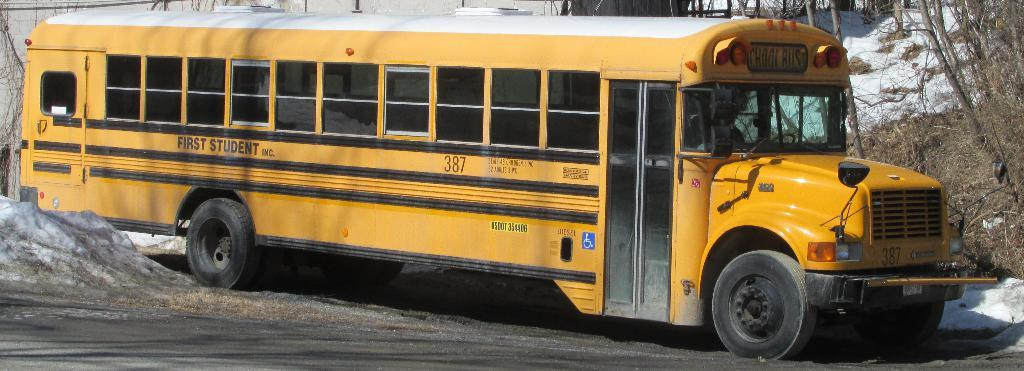What type of vehicle is in the image? There is a school bus in the image. What color is the school bus? The school bus is yellow. What can be seen in the background of the image? There are trees, a house, and snow visible in the background of the image. What type of gate is present in the image? There is no gate present in the image. What design can be seen on the school bus? The school bus is yellow and does not have any specific design mentioned in the facts. 